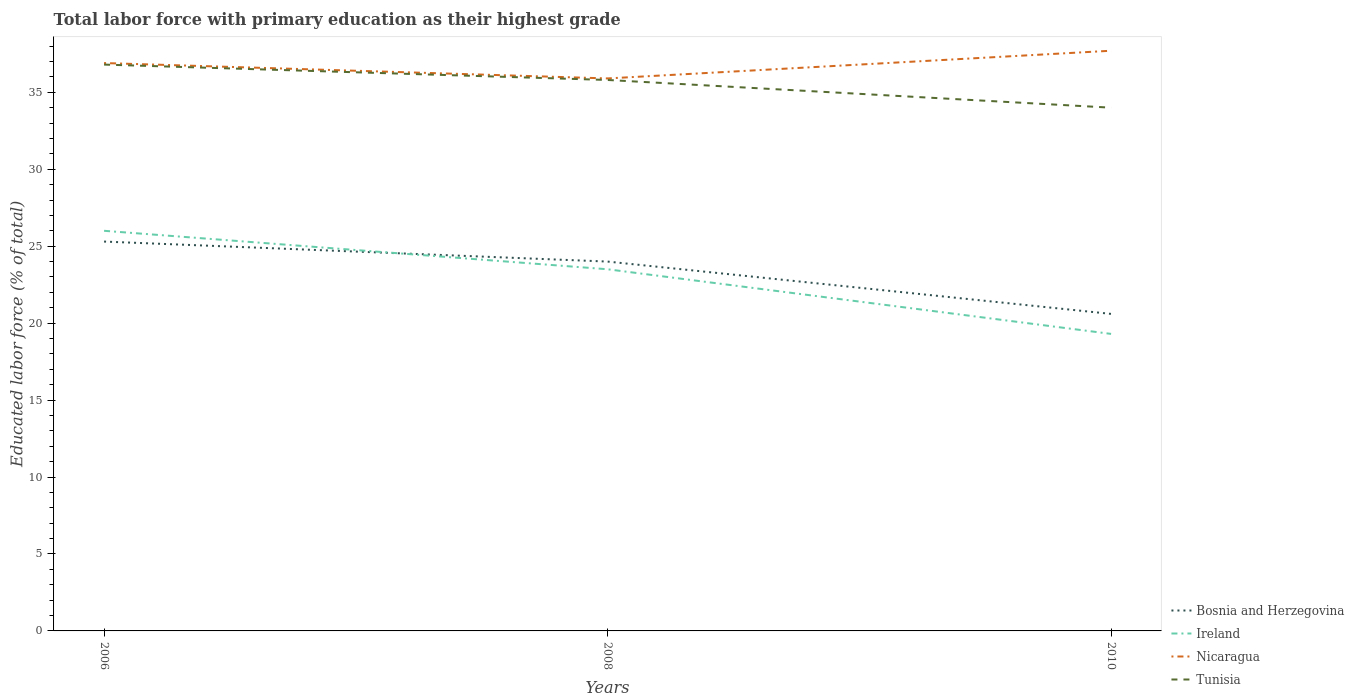Does the line corresponding to Bosnia and Herzegovina intersect with the line corresponding to Tunisia?
Your answer should be very brief. No. In which year was the percentage of total labor force with primary education in Ireland maximum?
Your response must be concise. 2010. What is the total percentage of total labor force with primary education in Tunisia in the graph?
Your response must be concise. 1. What is the difference between the highest and the second highest percentage of total labor force with primary education in Bosnia and Herzegovina?
Ensure brevity in your answer.  4.7. What is the difference between the highest and the lowest percentage of total labor force with primary education in Tunisia?
Make the answer very short. 2. Is the percentage of total labor force with primary education in Tunisia strictly greater than the percentage of total labor force with primary education in Ireland over the years?
Your answer should be very brief. No. Are the values on the major ticks of Y-axis written in scientific E-notation?
Keep it short and to the point. No. Does the graph contain grids?
Provide a short and direct response. No. Where does the legend appear in the graph?
Make the answer very short. Bottom right. How are the legend labels stacked?
Keep it short and to the point. Vertical. What is the title of the graph?
Provide a succinct answer. Total labor force with primary education as their highest grade. What is the label or title of the X-axis?
Offer a terse response. Years. What is the label or title of the Y-axis?
Ensure brevity in your answer.  Educated labor force (% of total). What is the Educated labor force (% of total) in Bosnia and Herzegovina in 2006?
Your response must be concise. 25.3. What is the Educated labor force (% of total) in Nicaragua in 2006?
Give a very brief answer. 36.9. What is the Educated labor force (% of total) of Tunisia in 2006?
Your answer should be compact. 36.8. What is the Educated labor force (% of total) of Nicaragua in 2008?
Make the answer very short. 35.9. What is the Educated labor force (% of total) of Tunisia in 2008?
Your response must be concise. 35.8. What is the Educated labor force (% of total) of Bosnia and Herzegovina in 2010?
Keep it short and to the point. 20.6. What is the Educated labor force (% of total) in Ireland in 2010?
Offer a very short reply. 19.3. What is the Educated labor force (% of total) in Nicaragua in 2010?
Keep it short and to the point. 37.7. What is the Educated labor force (% of total) of Tunisia in 2010?
Provide a succinct answer. 34. Across all years, what is the maximum Educated labor force (% of total) of Bosnia and Herzegovina?
Offer a very short reply. 25.3. Across all years, what is the maximum Educated labor force (% of total) of Nicaragua?
Your answer should be compact. 37.7. Across all years, what is the maximum Educated labor force (% of total) in Tunisia?
Your response must be concise. 36.8. Across all years, what is the minimum Educated labor force (% of total) in Bosnia and Herzegovina?
Provide a succinct answer. 20.6. Across all years, what is the minimum Educated labor force (% of total) in Ireland?
Ensure brevity in your answer.  19.3. Across all years, what is the minimum Educated labor force (% of total) of Nicaragua?
Ensure brevity in your answer.  35.9. Across all years, what is the minimum Educated labor force (% of total) in Tunisia?
Make the answer very short. 34. What is the total Educated labor force (% of total) of Bosnia and Herzegovina in the graph?
Your answer should be very brief. 69.9. What is the total Educated labor force (% of total) of Ireland in the graph?
Offer a terse response. 68.8. What is the total Educated labor force (% of total) in Nicaragua in the graph?
Provide a short and direct response. 110.5. What is the total Educated labor force (% of total) in Tunisia in the graph?
Offer a very short reply. 106.6. What is the difference between the Educated labor force (% of total) in Bosnia and Herzegovina in 2006 and that in 2008?
Provide a succinct answer. 1.3. What is the difference between the Educated labor force (% of total) in Ireland in 2006 and that in 2008?
Offer a very short reply. 2.5. What is the difference between the Educated labor force (% of total) in Tunisia in 2006 and that in 2008?
Offer a very short reply. 1. What is the difference between the Educated labor force (% of total) in Bosnia and Herzegovina in 2006 and that in 2010?
Provide a succinct answer. 4.7. What is the difference between the Educated labor force (% of total) in Ireland in 2006 and that in 2010?
Your answer should be very brief. 6.7. What is the difference between the Educated labor force (% of total) of Nicaragua in 2008 and that in 2010?
Provide a short and direct response. -1.8. What is the difference between the Educated labor force (% of total) of Bosnia and Herzegovina in 2006 and the Educated labor force (% of total) of Ireland in 2008?
Your answer should be compact. 1.8. What is the difference between the Educated labor force (% of total) of Bosnia and Herzegovina in 2006 and the Educated labor force (% of total) of Nicaragua in 2008?
Offer a terse response. -10.6. What is the difference between the Educated labor force (% of total) in Bosnia and Herzegovina in 2006 and the Educated labor force (% of total) in Tunisia in 2008?
Offer a very short reply. -10.5. What is the difference between the Educated labor force (% of total) in Nicaragua in 2006 and the Educated labor force (% of total) in Tunisia in 2008?
Provide a succinct answer. 1.1. What is the difference between the Educated labor force (% of total) of Bosnia and Herzegovina in 2006 and the Educated labor force (% of total) of Ireland in 2010?
Your answer should be very brief. 6. What is the difference between the Educated labor force (% of total) of Bosnia and Herzegovina in 2006 and the Educated labor force (% of total) of Tunisia in 2010?
Your answer should be compact. -8.7. What is the difference between the Educated labor force (% of total) of Bosnia and Herzegovina in 2008 and the Educated labor force (% of total) of Nicaragua in 2010?
Provide a succinct answer. -13.7. What is the difference between the Educated labor force (% of total) of Bosnia and Herzegovina in 2008 and the Educated labor force (% of total) of Tunisia in 2010?
Keep it short and to the point. -10. What is the difference between the Educated labor force (% of total) in Nicaragua in 2008 and the Educated labor force (% of total) in Tunisia in 2010?
Offer a terse response. 1.9. What is the average Educated labor force (% of total) of Bosnia and Herzegovina per year?
Your response must be concise. 23.3. What is the average Educated labor force (% of total) of Ireland per year?
Your answer should be very brief. 22.93. What is the average Educated labor force (% of total) of Nicaragua per year?
Your answer should be very brief. 36.83. What is the average Educated labor force (% of total) of Tunisia per year?
Keep it short and to the point. 35.53. In the year 2006, what is the difference between the Educated labor force (% of total) of Bosnia and Herzegovina and Educated labor force (% of total) of Nicaragua?
Offer a terse response. -11.6. In the year 2006, what is the difference between the Educated labor force (% of total) of Bosnia and Herzegovina and Educated labor force (% of total) of Tunisia?
Give a very brief answer. -11.5. In the year 2006, what is the difference between the Educated labor force (% of total) in Ireland and Educated labor force (% of total) in Nicaragua?
Keep it short and to the point. -10.9. In the year 2006, what is the difference between the Educated labor force (% of total) in Ireland and Educated labor force (% of total) in Tunisia?
Provide a short and direct response. -10.8. In the year 2008, what is the difference between the Educated labor force (% of total) of Bosnia and Herzegovina and Educated labor force (% of total) of Tunisia?
Make the answer very short. -11.8. In the year 2008, what is the difference between the Educated labor force (% of total) of Ireland and Educated labor force (% of total) of Tunisia?
Offer a very short reply. -12.3. In the year 2010, what is the difference between the Educated labor force (% of total) of Bosnia and Herzegovina and Educated labor force (% of total) of Nicaragua?
Your answer should be compact. -17.1. In the year 2010, what is the difference between the Educated labor force (% of total) in Ireland and Educated labor force (% of total) in Nicaragua?
Make the answer very short. -18.4. In the year 2010, what is the difference between the Educated labor force (% of total) in Ireland and Educated labor force (% of total) in Tunisia?
Offer a very short reply. -14.7. What is the ratio of the Educated labor force (% of total) of Bosnia and Herzegovina in 2006 to that in 2008?
Provide a succinct answer. 1.05. What is the ratio of the Educated labor force (% of total) of Ireland in 2006 to that in 2008?
Make the answer very short. 1.11. What is the ratio of the Educated labor force (% of total) in Nicaragua in 2006 to that in 2008?
Your answer should be compact. 1.03. What is the ratio of the Educated labor force (% of total) in Tunisia in 2006 to that in 2008?
Your answer should be compact. 1.03. What is the ratio of the Educated labor force (% of total) in Bosnia and Herzegovina in 2006 to that in 2010?
Your response must be concise. 1.23. What is the ratio of the Educated labor force (% of total) in Ireland in 2006 to that in 2010?
Make the answer very short. 1.35. What is the ratio of the Educated labor force (% of total) of Nicaragua in 2006 to that in 2010?
Your answer should be very brief. 0.98. What is the ratio of the Educated labor force (% of total) in Tunisia in 2006 to that in 2010?
Offer a very short reply. 1.08. What is the ratio of the Educated labor force (% of total) in Bosnia and Herzegovina in 2008 to that in 2010?
Keep it short and to the point. 1.17. What is the ratio of the Educated labor force (% of total) of Ireland in 2008 to that in 2010?
Your answer should be compact. 1.22. What is the ratio of the Educated labor force (% of total) in Nicaragua in 2008 to that in 2010?
Ensure brevity in your answer.  0.95. What is the ratio of the Educated labor force (% of total) in Tunisia in 2008 to that in 2010?
Ensure brevity in your answer.  1.05. What is the difference between the highest and the second highest Educated labor force (% of total) in Bosnia and Herzegovina?
Provide a succinct answer. 1.3. What is the difference between the highest and the second highest Educated labor force (% of total) in Tunisia?
Your answer should be very brief. 1. What is the difference between the highest and the lowest Educated labor force (% of total) in Bosnia and Herzegovina?
Make the answer very short. 4.7. What is the difference between the highest and the lowest Educated labor force (% of total) in Ireland?
Keep it short and to the point. 6.7. 